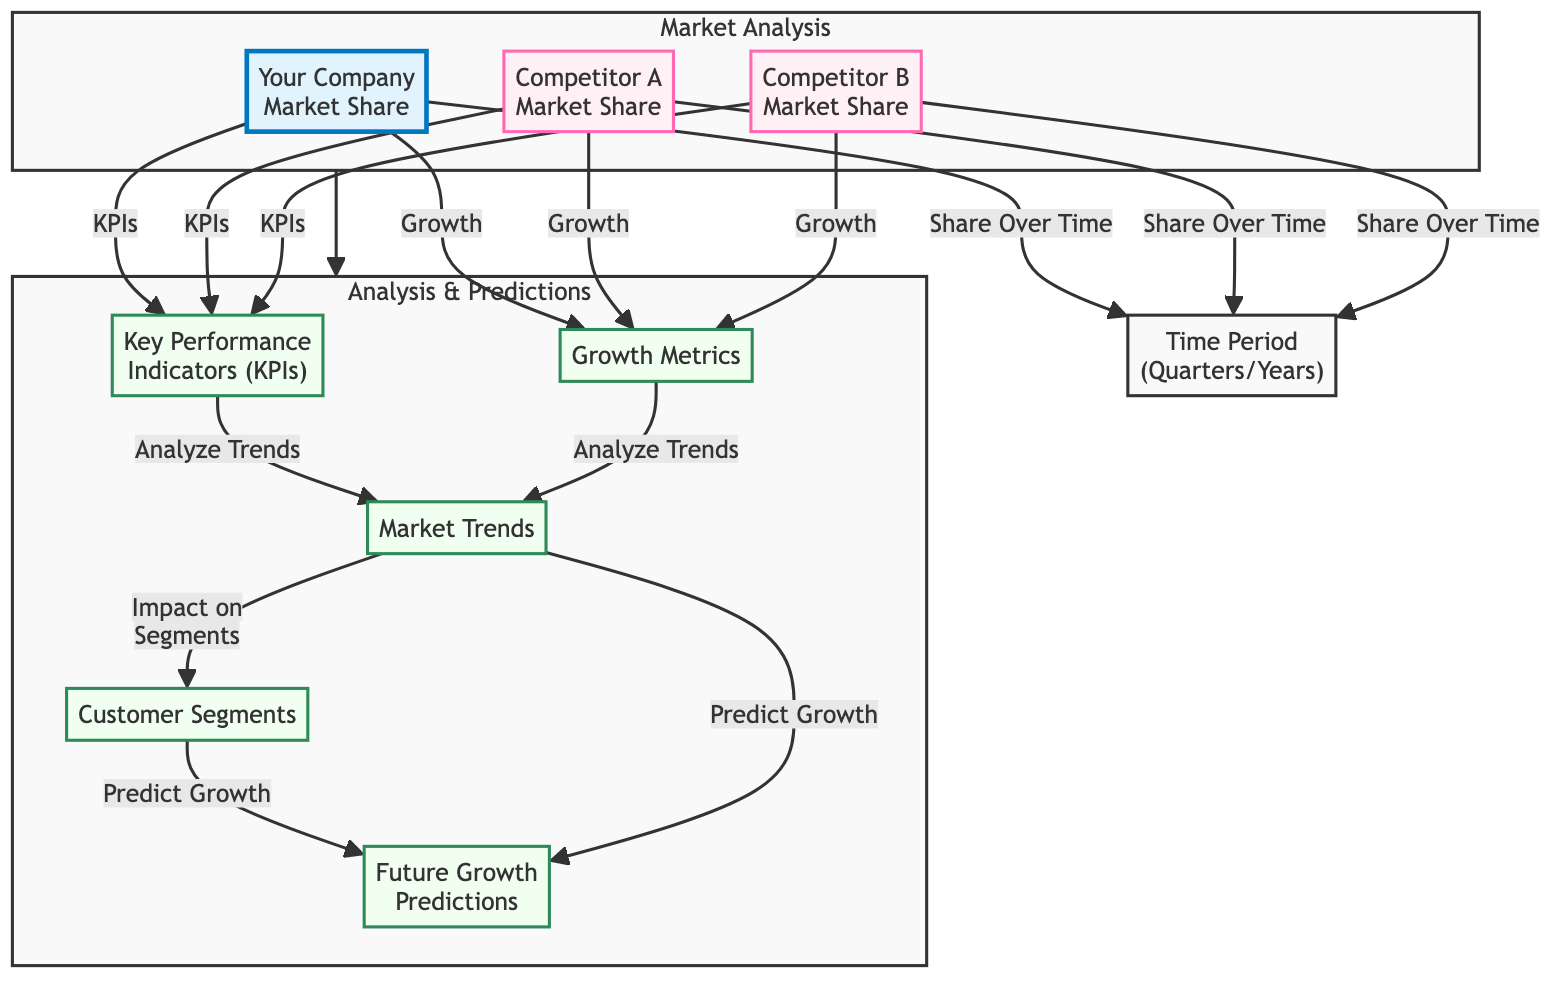What is shown at the top of the diagram? The top of the diagram displays the nodes representing "Your Company Market Share," "Competitor A Market Share," and "Competitor B Market Share." These nodes indicate the specific market share of the company and its competitors.
Answer: Your Company Market Share, Competitor A Market Share, Competitor B Market Share How many competitor market shares are analyzed in the diagram? The diagram includes two nodes for competitor market shares: "Competitor A Market Share" and "Competitor B Market Share." Therefore, the analysis assesses the market shares of two competitors.
Answer: Two What does the node 'key performance indicators' connect to in the diagram? The node 'key performance indicators' connects to three market shares nodes: 'Your Company Market Share,' 'Competitor A Market Share,' and 'Competitor B Market Share.' This indicates that KPIs are relevant for assessing all market shares.
Answer: Your Company Market Share, Competitor A Market Share, Competitor B Market Share Which nodes are impacted by market trends? The node 'market trends' impacts two subsequent nodes: 'customer segments' and 'predictions.' This shows the relationship between market trends and the resulting customer analysis and growth predictions.
Answer: Customer segments, Predictions How do growth metrics relate to key performance indicators in this diagram? The 'growth metrics' node connects to the 'key performance indicators' node, indicating that growth metrics are analyzed alongside KPIs to assess their relationships and impact on the market analysis.
Answer: They connect directly Which component provides predictions about future growth? The node 'predictions' derives its insights from both the 'market trends' and 'customer segments' nodes, showing that it forecasts future growth based on trends and segment analysis.
Answer: Predictions What analysis does the diagram facilitate regarding customer segments? The diagram shows that 'customer segments' provide insights that are used in 'predictions,' indicating an analysis of how different customer groups might change over time or affect future growth.
Answer: Predicting growth What type of diagram is being presented? The diagram is a textbook diagram, which typically organizes information visually to explain concepts, relationships, and data flow. This particular one focuses on competitive benchmarking of market share.
Answer: Textbook Diagram 